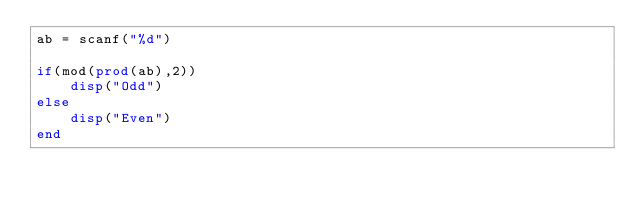Convert code to text. <code><loc_0><loc_0><loc_500><loc_500><_Octave_>ab = scanf("%d")

if(mod(prod(ab),2))
    disp("Odd")
else
    disp("Even")
end</code> 